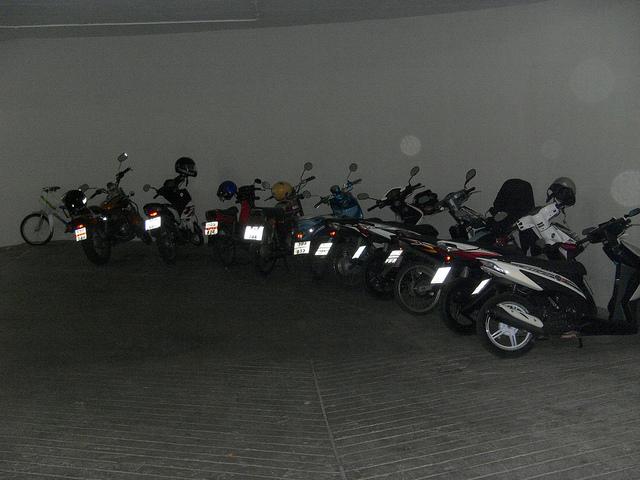Are these motorized bikes?
Short answer required. Yes. Where are these bikes displayed?
Write a very short answer. Garage. Are these bikes antique?
Keep it brief. No. Where does it look like this bikes are parked?
Write a very short answer. Garage. How many bikes are there?
Be succinct. 11. Are the train lights turned on?
Keep it brief. No. 